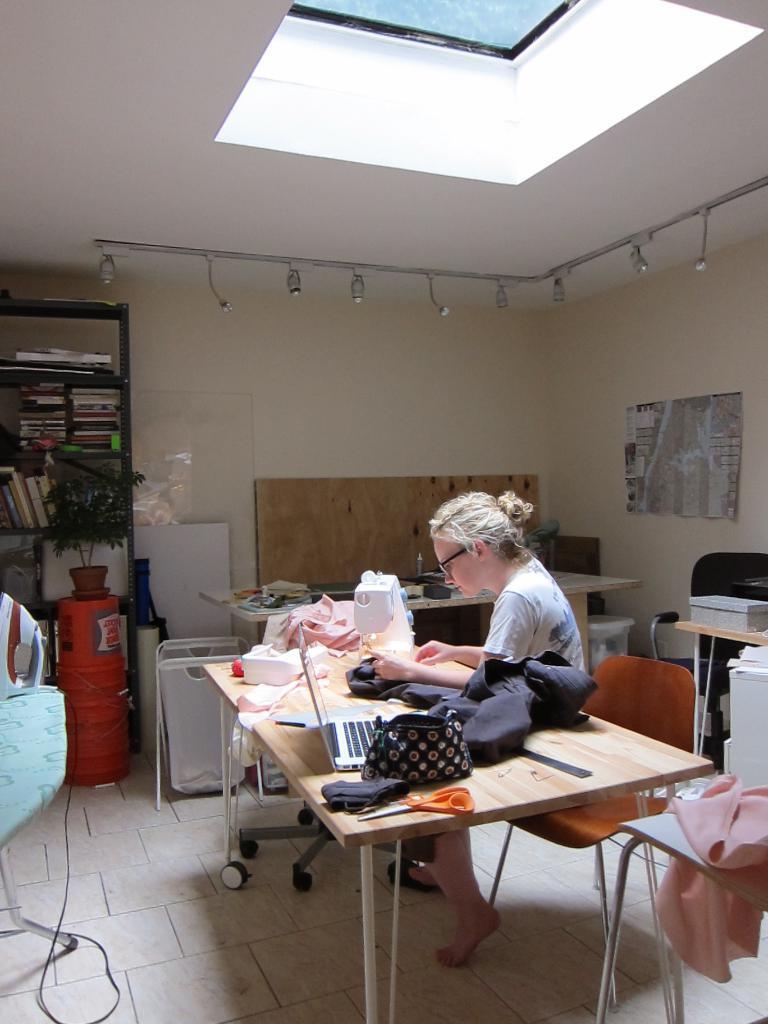How would you summarize this image in a sentence or two? Woman sitting on the chair on the table we have purse,sewing machine,in the back we have shelf with books and a plant. 